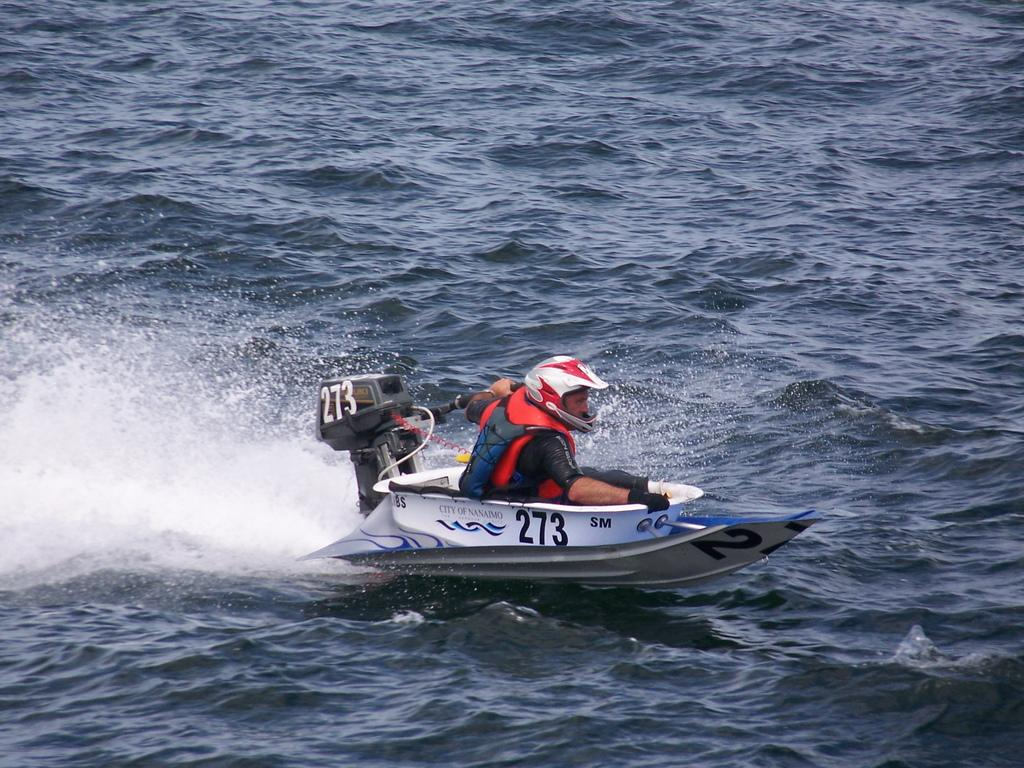Who is in the image? There is a person in the image. What is the person doing in the image? The person is in a speed boat. What is the person wearing in the image? The person is wearing a dress and helmet. Where is the speed boat located in the image? The speed boat is on the water. What type of oatmeal is being served on the land in the image? There is no oatmeal or land present in the image; it features a person in a speed boat on the water. 